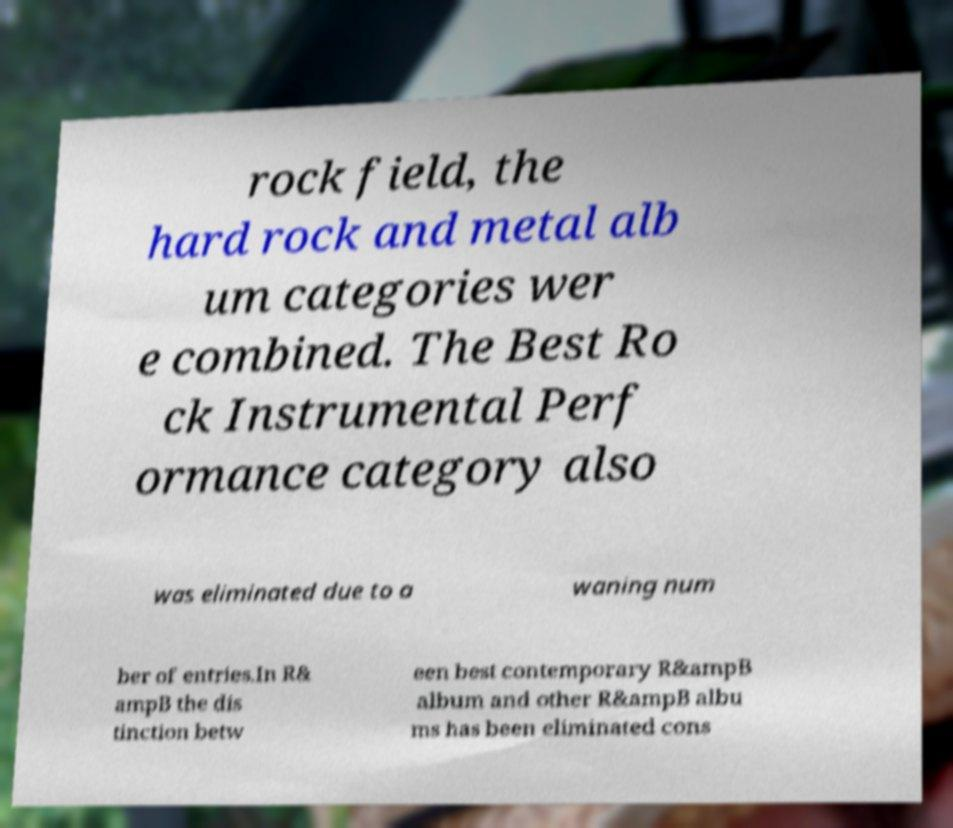Could you extract and type out the text from this image? rock field, the hard rock and metal alb um categories wer e combined. The Best Ro ck Instrumental Perf ormance category also was eliminated due to a waning num ber of entries.In R& ampB the dis tinction betw een best contemporary R&ampB album and other R&ampB albu ms has been eliminated cons 